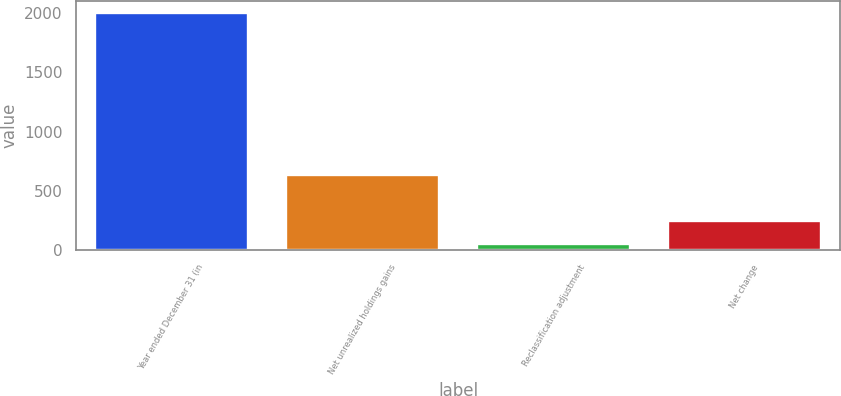<chart> <loc_0><loc_0><loc_500><loc_500><bar_chart><fcel>Year ended December 31 (in<fcel>Net unrealized holdings gains<fcel>Reclassification adjustment<fcel>Net change<nl><fcel>2001<fcel>636<fcel>51<fcel>246<nl></chart> 